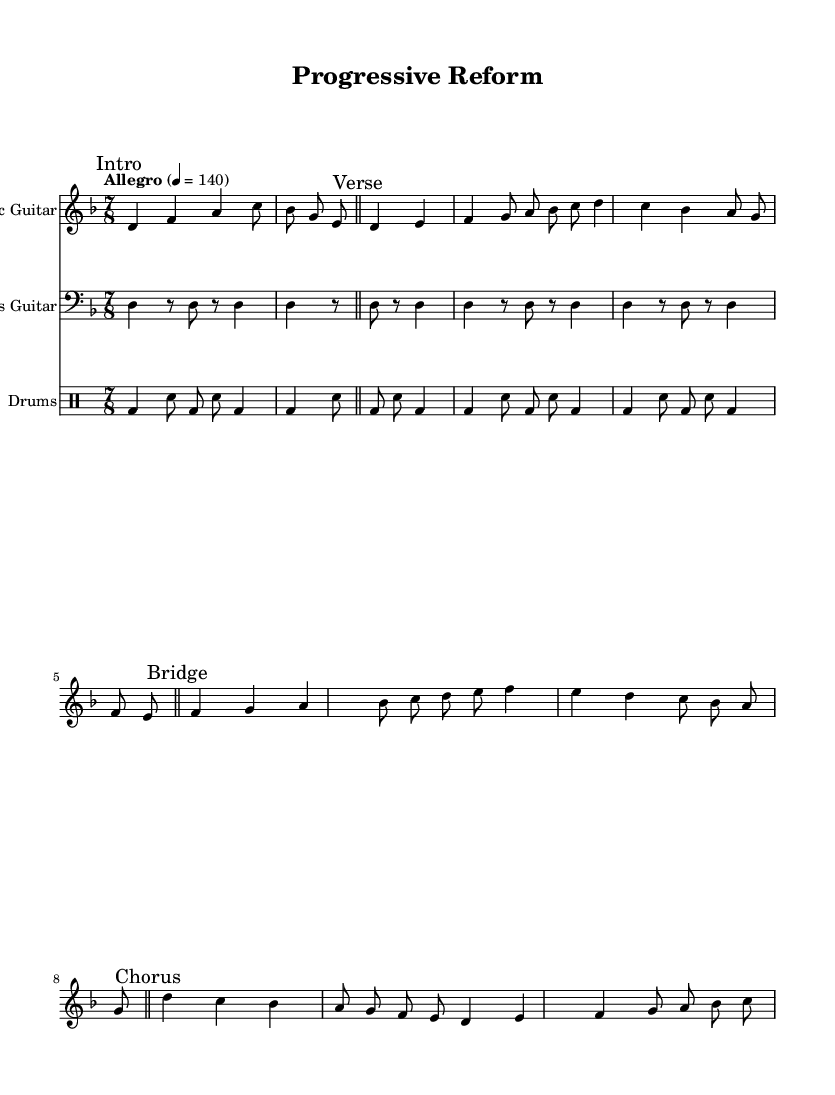What is the key signature of this music? The key signature is D minor, indicated at the beginning of the score with one flat, which corresponds to the natural minor scale based on D.
Answer: D minor What is the time signature of this composition? The time signature is 7/8, which is shown prominently at the beginning of the score, indicating seven eighth notes per measure.
Answer: 7/8 What is the tempo marking for the piece? The tempo marking is "Allegro" with a metronome setting of 4 = 140, indicating a fast and lively pace. This can be found at the beginning of the score.
Answer: Allegro, 4 = 140 How many measures are there in the verse section? The verse section has four measures, each containing a combination of quarter and eighth notes, as indicated in the notation beneath the "Verse" marking.
Answer: 4 What type of rhythm is predominantly used in the bass guitar part? The bass guitar part features a steady rhythm pattern of quarter and eighth notes, creating a consistent pulse that supports the other instruments.
Answer: Steady rhythm Which instrument has an intro section in the score? The electric guitar has an intro section marked “Intro”, where it plays a series of notes to initiate the piece, indicating a distinct starting point for the music.
Answer: Electric Guitar What is the dynamic marking for the electric guitar part? The electric guitar part is indicated to have dynamics marked as “Up,” suggesting that the dynamics are intended to be played with a more pronounced and brighter articulation.
Answer: Up 